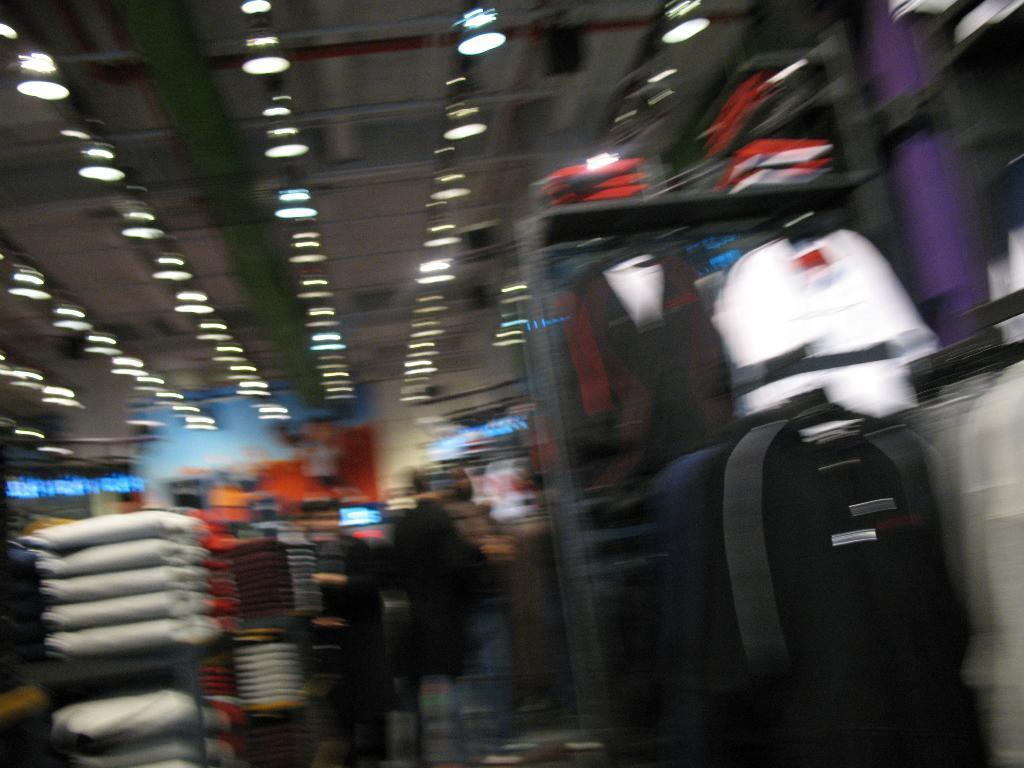What type of clothing can be seen on the right side of the image? There are dresses on the right side of the image. What is hanging from the ceiling in the image? There are lights on the ceiling in the image. What can be found on the cupboards in the image? There are items on the cupboards in the image. How many cattle are present in the image? There are no cattle present in the image. What type of soda is being served in the image? There is no soda present in the image. 